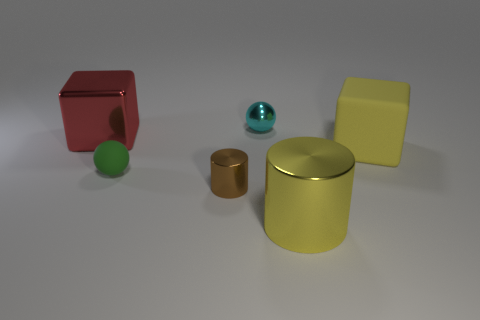What number of cubes are in front of the big shiny object that is to the right of the small ball that is behind the red shiny cube?
Make the answer very short. 0. What is the material of the cyan thing that is the same shape as the green thing?
Your answer should be compact. Metal. What is the object that is both on the right side of the brown metal cylinder and in front of the rubber block made of?
Your response must be concise. Metal. Is the number of big yellow cubes in front of the yellow matte thing less than the number of small metal objects that are behind the red metallic thing?
Offer a terse response. Yes. How many other things are there of the same size as the green rubber sphere?
Provide a short and direct response. 2. What is the shape of the big metal thing behind the big block that is to the right of the rubber thing left of the big matte cube?
Keep it short and to the point. Cube. How many yellow objects are rubber blocks or tiny metallic cylinders?
Give a very brief answer. 1. What number of big red blocks are right of the cube to the left of the tiny green matte object?
Offer a terse response. 0. Are there any other things that have the same color as the tiny rubber sphere?
Your response must be concise. No. What is the shape of the large object that is made of the same material as the small green ball?
Provide a short and direct response. Cube. 